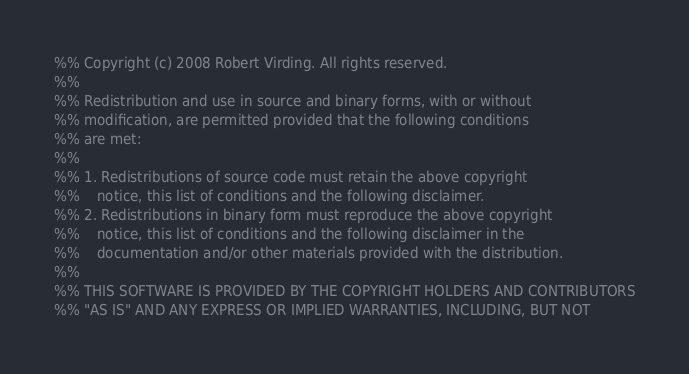Convert code to text. <code><loc_0><loc_0><loc_500><loc_500><_Erlang_>%% Copyright (c) 2008 Robert Virding. All rights reserved.
%%
%% Redistribution and use in source and binary forms, with or without
%% modification, are permitted provided that the following conditions
%% are met:
%%
%% 1. Redistributions of source code must retain the above copyright
%%    notice, this list of conditions and the following disclaimer.
%% 2. Redistributions in binary form must reproduce the above copyright
%%    notice, this list of conditions and the following disclaimer in the
%%    documentation and/or other materials provided with the distribution.
%%
%% THIS SOFTWARE IS PROVIDED BY THE COPYRIGHT HOLDERS AND CONTRIBUTORS
%% "AS IS" AND ANY EXPRESS OR IMPLIED WARRANTIES, INCLUDING, BUT NOT</code> 